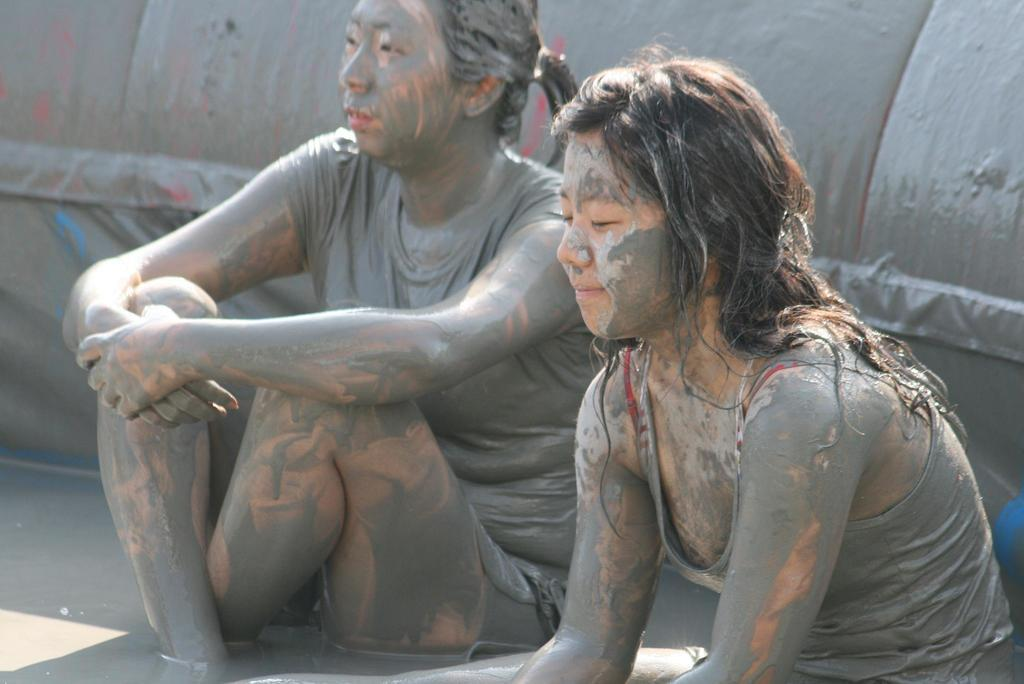How many people are in the image? There are two people in the image. What are the people wearing? The people are wearing dresses. What can be observed on the people and in the background of the image? The people have mud on them, and there is an object with mud in the background of the image. What is the weight of the wax in the image? There is no wax present in the image, so it is not possible to determine its weight. 